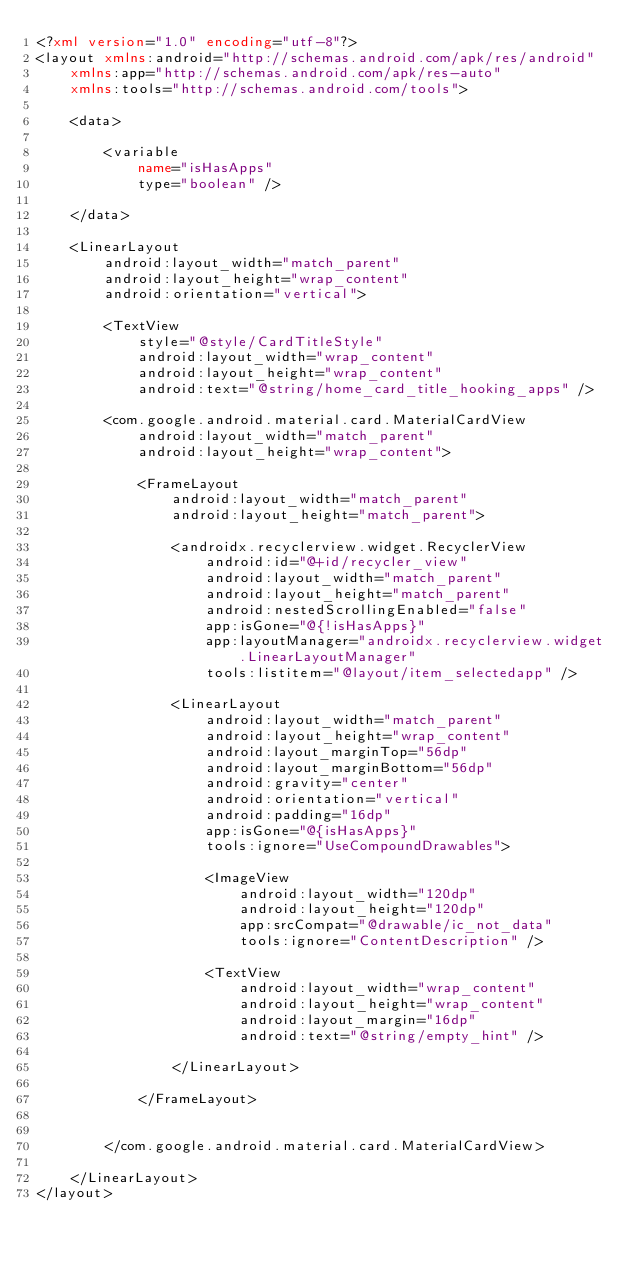Convert code to text. <code><loc_0><loc_0><loc_500><loc_500><_XML_><?xml version="1.0" encoding="utf-8"?>
<layout xmlns:android="http://schemas.android.com/apk/res/android"
    xmlns:app="http://schemas.android.com/apk/res-auto"
    xmlns:tools="http://schemas.android.com/tools">

    <data>

        <variable
            name="isHasApps"
            type="boolean" />

    </data>

    <LinearLayout
        android:layout_width="match_parent"
        android:layout_height="wrap_content"
        android:orientation="vertical">

        <TextView
            style="@style/CardTitleStyle"
            android:layout_width="wrap_content"
            android:layout_height="wrap_content"
            android:text="@string/home_card_title_hooking_apps" />

        <com.google.android.material.card.MaterialCardView
            android:layout_width="match_parent"
            android:layout_height="wrap_content">

            <FrameLayout
                android:layout_width="match_parent"
                android:layout_height="match_parent">

                <androidx.recyclerview.widget.RecyclerView
                    android:id="@+id/recycler_view"
                    android:layout_width="match_parent"
                    android:layout_height="match_parent"
                    android:nestedScrollingEnabled="false"
                    app:isGone="@{!isHasApps}"
                    app:layoutManager="androidx.recyclerview.widget.LinearLayoutManager"
                    tools:listitem="@layout/item_selectedapp" />

                <LinearLayout
                    android:layout_width="match_parent"
                    android:layout_height="wrap_content"
                    android:layout_marginTop="56dp"
                    android:layout_marginBottom="56dp"
                    android:gravity="center"
                    android:orientation="vertical"
                    android:padding="16dp"
                    app:isGone="@{isHasApps}"
                    tools:ignore="UseCompoundDrawables">

                    <ImageView
                        android:layout_width="120dp"
                        android:layout_height="120dp"
                        app:srcCompat="@drawable/ic_not_data"
                        tools:ignore="ContentDescription" />

                    <TextView
                        android:layout_width="wrap_content"
                        android:layout_height="wrap_content"
                        android:layout_margin="16dp"
                        android:text="@string/empty_hint" />

                </LinearLayout>

            </FrameLayout>


        </com.google.android.material.card.MaterialCardView>

    </LinearLayout>
</layout></code> 